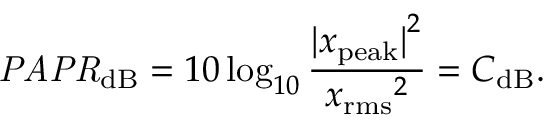Convert formula to latex. <formula><loc_0><loc_0><loc_500><loc_500>{ P A P R } _ { d B } = 1 0 \log _ { 1 0 } { \frac { { | x _ { p e a k } | } ^ { 2 } } { { x _ { r m s } } ^ { 2 } } } = C _ { d B } .</formula> 